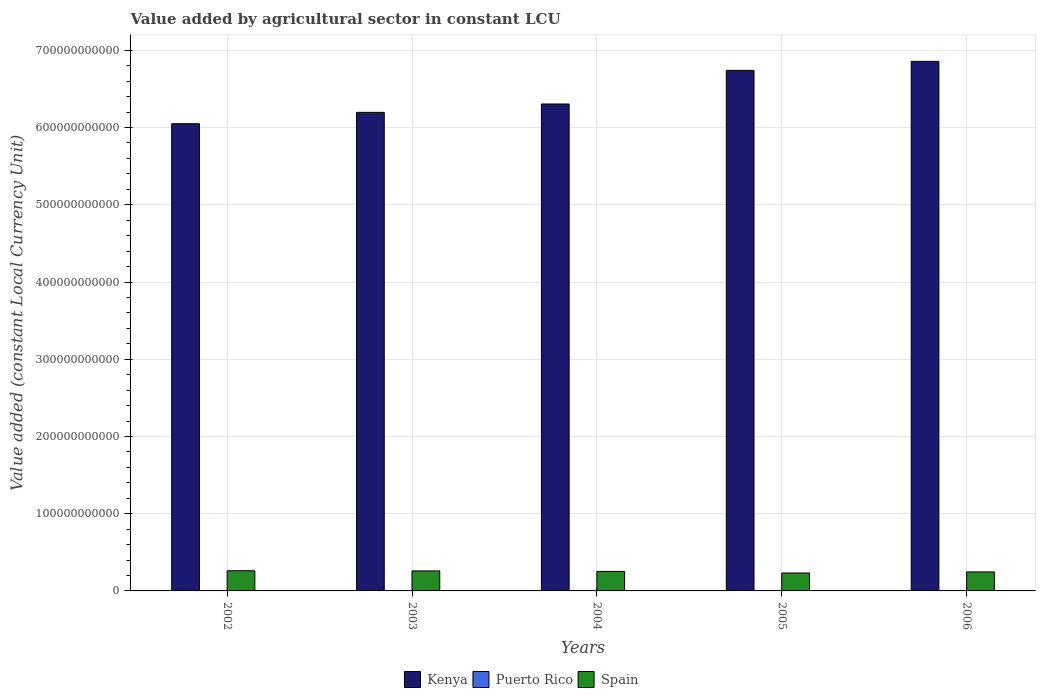Are the number of bars per tick equal to the number of legend labels?
Make the answer very short. Yes. What is the value added by agricultural sector in Spain in 2004?
Your response must be concise. 2.53e+1. Across all years, what is the maximum value added by agricultural sector in Puerto Rico?
Provide a short and direct response. 1.61e+08. Across all years, what is the minimum value added by agricultural sector in Spain?
Make the answer very short. 2.32e+1. In which year was the value added by agricultural sector in Kenya maximum?
Provide a succinct answer. 2006. In which year was the value added by agricultural sector in Puerto Rico minimum?
Make the answer very short. 2002. What is the total value added by agricultural sector in Spain in the graph?
Offer a very short reply. 1.25e+11. What is the difference between the value added by agricultural sector in Kenya in 2003 and that in 2005?
Provide a succinct answer. -5.44e+1. What is the difference between the value added by agricultural sector in Kenya in 2006 and the value added by agricultural sector in Spain in 2004?
Offer a terse response. 6.60e+11. What is the average value added by agricultural sector in Puerto Rico per year?
Provide a short and direct response. 1.40e+08. In the year 2002, what is the difference between the value added by agricultural sector in Puerto Rico and value added by agricultural sector in Kenya?
Offer a very short reply. -6.05e+11. In how many years, is the value added by agricultural sector in Puerto Rico greater than 480000000000 LCU?
Your answer should be compact. 0. What is the ratio of the value added by agricultural sector in Spain in 2002 to that in 2006?
Make the answer very short. 1.06. Is the value added by agricultural sector in Puerto Rico in 2002 less than that in 2006?
Offer a terse response. Yes. What is the difference between the highest and the second highest value added by agricultural sector in Puerto Rico?
Keep it short and to the point. 1.14e+07. What is the difference between the highest and the lowest value added by agricultural sector in Kenya?
Provide a short and direct response. 8.07e+1. In how many years, is the value added by agricultural sector in Kenya greater than the average value added by agricultural sector in Kenya taken over all years?
Offer a terse response. 2. Is the sum of the value added by agricultural sector in Spain in 2003 and 2005 greater than the maximum value added by agricultural sector in Kenya across all years?
Your answer should be compact. No. What does the 1st bar from the left in 2003 represents?
Give a very brief answer. Kenya. What does the 3rd bar from the right in 2003 represents?
Your answer should be compact. Kenya. Are all the bars in the graph horizontal?
Offer a very short reply. No. How many years are there in the graph?
Your response must be concise. 5. What is the difference between two consecutive major ticks on the Y-axis?
Your response must be concise. 1.00e+11. Are the values on the major ticks of Y-axis written in scientific E-notation?
Your answer should be compact. No. What is the title of the graph?
Your response must be concise. Value added by agricultural sector in constant LCU. Does "Norway" appear as one of the legend labels in the graph?
Your response must be concise. No. What is the label or title of the Y-axis?
Provide a short and direct response. Value added (constant Local Currency Unit). What is the Value added (constant Local Currency Unit) of Kenya in 2002?
Ensure brevity in your answer.  6.05e+11. What is the Value added (constant Local Currency Unit) in Puerto Rico in 2002?
Your response must be concise. 1.13e+08. What is the Value added (constant Local Currency Unit) of Spain in 2002?
Your answer should be compact. 2.61e+1. What is the Value added (constant Local Currency Unit) of Kenya in 2003?
Make the answer very short. 6.20e+11. What is the Value added (constant Local Currency Unit) of Puerto Rico in 2003?
Offer a terse response. 1.30e+08. What is the Value added (constant Local Currency Unit) of Spain in 2003?
Give a very brief answer. 2.59e+1. What is the Value added (constant Local Currency Unit) of Kenya in 2004?
Offer a terse response. 6.31e+11. What is the Value added (constant Local Currency Unit) of Puerto Rico in 2004?
Your response must be concise. 1.61e+08. What is the Value added (constant Local Currency Unit) in Spain in 2004?
Provide a succinct answer. 2.53e+1. What is the Value added (constant Local Currency Unit) in Kenya in 2005?
Provide a succinct answer. 6.74e+11. What is the Value added (constant Local Currency Unit) in Puerto Rico in 2005?
Offer a terse response. 1.49e+08. What is the Value added (constant Local Currency Unit) of Spain in 2005?
Provide a succinct answer. 2.32e+1. What is the Value added (constant Local Currency Unit) of Kenya in 2006?
Provide a short and direct response. 6.86e+11. What is the Value added (constant Local Currency Unit) of Puerto Rico in 2006?
Ensure brevity in your answer.  1.50e+08. What is the Value added (constant Local Currency Unit) of Spain in 2006?
Your answer should be compact. 2.46e+1. Across all years, what is the maximum Value added (constant Local Currency Unit) of Kenya?
Keep it short and to the point. 6.86e+11. Across all years, what is the maximum Value added (constant Local Currency Unit) of Puerto Rico?
Ensure brevity in your answer.  1.61e+08. Across all years, what is the maximum Value added (constant Local Currency Unit) in Spain?
Your answer should be very brief. 2.61e+1. Across all years, what is the minimum Value added (constant Local Currency Unit) of Kenya?
Provide a succinct answer. 6.05e+11. Across all years, what is the minimum Value added (constant Local Currency Unit) of Puerto Rico?
Provide a short and direct response. 1.13e+08. Across all years, what is the minimum Value added (constant Local Currency Unit) of Spain?
Your response must be concise. 2.32e+1. What is the total Value added (constant Local Currency Unit) of Kenya in the graph?
Ensure brevity in your answer.  3.21e+12. What is the total Value added (constant Local Currency Unit) in Puerto Rico in the graph?
Provide a short and direct response. 7.02e+08. What is the total Value added (constant Local Currency Unit) of Spain in the graph?
Your response must be concise. 1.25e+11. What is the difference between the Value added (constant Local Currency Unit) in Kenya in 2002 and that in 2003?
Provide a short and direct response. -1.47e+1. What is the difference between the Value added (constant Local Currency Unit) of Puerto Rico in 2002 and that in 2003?
Your response must be concise. -1.62e+07. What is the difference between the Value added (constant Local Currency Unit) in Spain in 2002 and that in 2003?
Keep it short and to the point. 2.04e+08. What is the difference between the Value added (constant Local Currency Unit) in Kenya in 2002 and that in 2004?
Your response must be concise. -2.55e+1. What is the difference between the Value added (constant Local Currency Unit) in Puerto Rico in 2002 and that in 2004?
Provide a succinct answer. -4.76e+07. What is the difference between the Value added (constant Local Currency Unit) of Spain in 2002 and that in 2004?
Offer a very short reply. 8.60e+08. What is the difference between the Value added (constant Local Currency Unit) in Kenya in 2002 and that in 2005?
Ensure brevity in your answer.  -6.91e+1. What is the difference between the Value added (constant Local Currency Unit) in Puerto Rico in 2002 and that in 2005?
Your answer should be very brief. -3.53e+07. What is the difference between the Value added (constant Local Currency Unit) in Spain in 2002 and that in 2005?
Keep it short and to the point. 2.89e+09. What is the difference between the Value added (constant Local Currency Unit) in Kenya in 2002 and that in 2006?
Provide a short and direct response. -8.07e+1. What is the difference between the Value added (constant Local Currency Unit) of Puerto Rico in 2002 and that in 2006?
Your response must be concise. -3.62e+07. What is the difference between the Value added (constant Local Currency Unit) in Spain in 2002 and that in 2006?
Your answer should be very brief. 1.51e+09. What is the difference between the Value added (constant Local Currency Unit) in Kenya in 2003 and that in 2004?
Your response must be concise. -1.08e+1. What is the difference between the Value added (constant Local Currency Unit) in Puerto Rico in 2003 and that in 2004?
Provide a succinct answer. -3.14e+07. What is the difference between the Value added (constant Local Currency Unit) in Spain in 2003 and that in 2004?
Provide a short and direct response. 6.56e+08. What is the difference between the Value added (constant Local Currency Unit) in Kenya in 2003 and that in 2005?
Keep it short and to the point. -5.44e+1. What is the difference between the Value added (constant Local Currency Unit) of Puerto Rico in 2003 and that in 2005?
Provide a succinct answer. -1.91e+07. What is the difference between the Value added (constant Local Currency Unit) in Spain in 2003 and that in 2005?
Offer a terse response. 2.68e+09. What is the difference between the Value added (constant Local Currency Unit) in Kenya in 2003 and that in 2006?
Your answer should be compact. -6.60e+1. What is the difference between the Value added (constant Local Currency Unit) in Puerto Rico in 2003 and that in 2006?
Offer a very short reply. -2.00e+07. What is the difference between the Value added (constant Local Currency Unit) in Spain in 2003 and that in 2006?
Give a very brief answer. 1.31e+09. What is the difference between the Value added (constant Local Currency Unit) in Kenya in 2004 and that in 2005?
Provide a short and direct response. -4.35e+1. What is the difference between the Value added (constant Local Currency Unit) of Puerto Rico in 2004 and that in 2005?
Your answer should be compact. 1.24e+07. What is the difference between the Value added (constant Local Currency Unit) of Spain in 2004 and that in 2005?
Keep it short and to the point. 2.03e+09. What is the difference between the Value added (constant Local Currency Unit) of Kenya in 2004 and that in 2006?
Provide a succinct answer. -5.52e+1. What is the difference between the Value added (constant Local Currency Unit) in Puerto Rico in 2004 and that in 2006?
Provide a short and direct response. 1.14e+07. What is the difference between the Value added (constant Local Currency Unit) of Spain in 2004 and that in 2006?
Your answer should be very brief. 6.53e+08. What is the difference between the Value added (constant Local Currency Unit) in Kenya in 2005 and that in 2006?
Offer a very short reply. -1.17e+1. What is the difference between the Value added (constant Local Currency Unit) in Puerto Rico in 2005 and that in 2006?
Your answer should be compact. -9.53e+05. What is the difference between the Value added (constant Local Currency Unit) of Spain in 2005 and that in 2006?
Provide a succinct answer. -1.38e+09. What is the difference between the Value added (constant Local Currency Unit) of Kenya in 2002 and the Value added (constant Local Currency Unit) of Puerto Rico in 2003?
Provide a succinct answer. 6.05e+11. What is the difference between the Value added (constant Local Currency Unit) of Kenya in 2002 and the Value added (constant Local Currency Unit) of Spain in 2003?
Provide a short and direct response. 5.79e+11. What is the difference between the Value added (constant Local Currency Unit) of Puerto Rico in 2002 and the Value added (constant Local Currency Unit) of Spain in 2003?
Offer a very short reply. -2.58e+1. What is the difference between the Value added (constant Local Currency Unit) in Kenya in 2002 and the Value added (constant Local Currency Unit) in Puerto Rico in 2004?
Provide a succinct answer. 6.05e+11. What is the difference between the Value added (constant Local Currency Unit) in Kenya in 2002 and the Value added (constant Local Currency Unit) in Spain in 2004?
Ensure brevity in your answer.  5.80e+11. What is the difference between the Value added (constant Local Currency Unit) in Puerto Rico in 2002 and the Value added (constant Local Currency Unit) in Spain in 2004?
Keep it short and to the point. -2.51e+1. What is the difference between the Value added (constant Local Currency Unit) of Kenya in 2002 and the Value added (constant Local Currency Unit) of Puerto Rico in 2005?
Offer a very short reply. 6.05e+11. What is the difference between the Value added (constant Local Currency Unit) in Kenya in 2002 and the Value added (constant Local Currency Unit) in Spain in 2005?
Give a very brief answer. 5.82e+11. What is the difference between the Value added (constant Local Currency Unit) in Puerto Rico in 2002 and the Value added (constant Local Currency Unit) in Spain in 2005?
Offer a terse response. -2.31e+1. What is the difference between the Value added (constant Local Currency Unit) in Kenya in 2002 and the Value added (constant Local Currency Unit) in Puerto Rico in 2006?
Provide a short and direct response. 6.05e+11. What is the difference between the Value added (constant Local Currency Unit) in Kenya in 2002 and the Value added (constant Local Currency Unit) in Spain in 2006?
Your response must be concise. 5.80e+11. What is the difference between the Value added (constant Local Currency Unit) of Puerto Rico in 2002 and the Value added (constant Local Currency Unit) of Spain in 2006?
Your answer should be compact. -2.45e+1. What is the difference between the Value added (constant Local Currency Unit) of Kenya in 2003 and the Value added (constant Local Currency Unit) of Puerto Rico in 2004?
Your answer should be very brief. 6.20e+11. What is the difference between the Value added (constant Local Currency Unit) in Kenya in 2003 and the Value added (constant Local Currency Unit) in Spain in 2004?
Give a very brief answer. 5.94e+11. What is the difference between the Value added (constant Local Currency Unit) in Puerto Rico in 2003 and the Value added (constant Local Currency Unit) in Spain in 2004?
Make the answer very short. -2.51e+1. What is the difference between the Value added (constant Local Currency Unit) in Kenya in 2003 and the Value added (constant Local Currency Unit) in Puerto Rico in 2005?
Give a very brief answer. 6.20e+11. What is the difference between the Value added (constant Local Currency Unit) in Kenya in 2003 and the Value added (constant Local Currency Unit) in Spain in 2005?
Offer a terse response. 5.96e+11. What is the difference between the Value added (constant Local Currency Unit) of Puerto Rico in 2003 and the Value added (constant Local Currency Unit) of Spain in 2005?
Your answer should be very brief. -2.31e+1. What is the difference between the Value added (constant Local Currency Unit) in Kenya in 2003 and the Value added (constant Local Currency Unit) in Puerto Rico in 2006?
Make the answer very short. 6.20e+11. What is the difference between the Value added (constant Local Currency Unit) in Kenya in 2003 and the Value added (constant Local Currency Unit) in Spain in 2006?
Your response must be concise. 5.95e+11. What is the difference between the Value added (constant Local Currency Unit) of Puerto Rico in 2003 and the Value added (constant Local Currency Unit) of Spain in 2006?
Your answer should be very brief. -2.45e+1. What is the difference between the Value added (constant Local Currency Unit) of Kenya in 2004 and the Value added (constant Local Currency Unit) of Puerto Rico in 2005?
Your answer should be very brief. 6.30e+11. What is the difference between the Value added (constant Local Currency Unit) of Kenya in 2004 and the Value added (constant Local Currency Unit) of Spain in 2005?
Offer a terse response. 6.07e+11. What is the difference between the Value added (constant Local Currency Unit) of Puerto Rico in 2004 and the Value added (constant Local Currency Unit) of Spain in 2005?
Give a very brief answer. -2.31e+1. What is the difference between the Value added (constant Local Currency Unit) of Kenya in 2004 and the Value added (constant Local Currency Unit) of Puerto Rico in 2006?
Offer a terse response. 6.30e+11. What is the difference between the Value added (constant Local Currency Unit) in Kenya in 2004 and the Value added (constant Local Currency Unit) in Spain in 2006?
Offer a very short reply. 6.06e+11. What is the difference between the Value added (constant Local Currency Unit) in Puerto Rico in 2004 and the Value added (constant Local Currency Unit) in Spain in 2006?
Offer a terse response. -2.44e+1. What is the difference between the Value added (constant Local Currency Unit) of Kenya in 2005 and the Value added (constant Local Currency Unit) of Puerto Rico in 2006?
Your answer should be compact. 6.74e+11. What is the difference between the Value added (constant Local Currency Unit) in Kenya in 2005 and the Value added (constant Local Currency Unit) in Spain in 2006?
Your answer should be compact. 6.49e+11. What is the difference between the Value added (constant Local Currency Unit) of Puerto Rico in 2005 and the Value added (constant Local Currency Unit) of Spain in 2006?
Offer a very short reply. -2.45e+1. What is the average Value added (constant Local Currency Unit) of Kenya per year?
Offer a terse response. 6.43e+11. What is the average Value added (constant Local Currency Unit) of Puerto Rico per year?
Ensure brevity in your answer.  1.40e+08. What is the average Value added (constant Local Currency Unit) in Spain per year?
Offer a terse response. 2.50e+1. In the year 2002, what is the difference between the Value added (constant Local Currency Unit) of Kenya and Value added (constant Local Currency Unit) of Puerto Rico?
Your answer should be compact. 6.05e+11. In the year 2002, what is the difference between the Value added (constant Local Currency Unit) of Kenya and Value added (constant Local Currency Unit) of Spain?
Provide a short and direct response. 5.79e+11. In the year 2002, what is the difference between the Value added (constant Local Currency Unit) of Puerto Rico and Value added (constant Local Currency Unit) of Spain?
Your answer should be compact. -2.60e+1. In the year 2003, what is the difference between the Value added (constant Local Currency Unit) of Kenya and Value added (constant Local Currency Unit) of Puerto Rico?
Offer a terse response. 6.20e+11. In the year 2003, what is the difference between the Value added (constant Local Currency Unit) of Kenya and Value added (constant Local Currency Unit) of Spain?
Your answer should be compact. 5.94e+11. In the year 2003, what is the difference between the Value added (constant Local Currency Unit) in Puerto Rico and Value added (constant Local Currency Unit) in Spain?
Provide a succinct answer. -2.58e+1. In the year 2004, what is the difference between the Value added (constant Local Currency Unit) in Kenya and Value added (constant Local Currency Unit) in Puerto Rico?
Offer a very short reply. 6.30e+11. In the year 2004, what is the difference between the Value added (constant Local Currency Unit) of Kenya and Value added (constant Local Currency Unit) of Spain?
Offer a very short reply. 6.05e+11. In the year 2004, what is the difference between the Value added (constant Local Currency Unit) in Puerto Rico and Value added (constant Local Currency Unit) in Spain?
Offer a terse response. -2.51e+1. In the year 2005, what is the difference between the Value added (constant Local Currency Unit) of Kenya and Value added (constant Local Currency Unit) of Puerto Rico?
Make the answer very short. 6.74e+11. In the year 2005, what is the difference between the Value added (constant Local Currency Unit) of Kenya and Value added (constant Local Currency Unit) of Spain?
Your answer should be compact. 6.51e+11. In the year 2005, what is the difference between the Value added (constant Local Currency Unit) of Puerto Rico and Value added (constant Local Currency Unit) of Spain?
Your response must be concise. -2.31e+1. In the year 2006, what is the difference between the Value added (constant Local Currency Unit) of Kenya and Value added (constant Local Currency Unit) of Puerto Rico?
Give a very brief answer. 6.86e+11. In the year 2006, what is the difference between the Value added (constant Local Currency Unit) in Kenya and Value added (constant Local Currency Unit) in Spain?
Offer a very short reply. 6.61e+11. In the year 2006, what is the difference between the Value added (constant Local Currency Unit) in Puerto Rico and Value added (constant Local Currency Unit) in Spain?
Ensure brevity in your answer.  -2.45e+1. What is the ratio of the Value added (constant Local Currency Unit) in Kenya in 2002 to that in 2003?
Your answer should be very brief. 0.98. What is the ratio of the Value added (constant Local Currency Unit) in Puerto Rico in 2002 to that in 2003?
Offer a very short reply. 0.88. What is the ratio of the Value added (constant Local Currency Unit) of Spain in 2002 to that in 2003?
Offer a very short reply. 1.01. What is the ratio of the Value added (constant Local Currency Unit) of Kenya in 2002 to that in 2004?
Your response must be concise. 0.96. What is the ratio of the Value added (constant Local Currency Unit) of Puerto Rico in 2002 to that in 2004?
Provide a succinct answer. 0.7. What is the ratio of the Value added (constant Local Currency Unit) in Spain in 2002 to that in 2004?
Provide a short and direct response. 1.03. What is the ratio of the Value added (constant Local Currency Unit) in Kenya in 2002 to that in 2005?
Offer a terse response. 0.9. What is the ratio of the Value added (constant Local Currency Unit) of Puerto Rico in 2002 to that in 2005?
Ensure brevity in your answer.  0.76. What is the ratio of the Value added (constant Local Currency Unit) of Spain in 2002 to that in 2005?
Offer a terse response. 1.12. What is the ratio of the Value added (constant Local Currency Unit) in Kenya in 2002 to that in 2006?
Keep it short and to the point. 0.88. What is the ratio of the Value added (constant Local Currency Unit) of Puerto Rico in 2002 to that in 2006?
Make the answer very short. 0.76. What is the ratio of the Value added (constant Local Currency Unit) of Spain in 2002 to that in 2006?
Make the answer very short. 1.06. What is the ratio of the Value added (constant Local Currency Unit) in Kenya in 2003 to that in 2004?
Offer a very short reply. 0.98. What is the ratio of the Value added (constant Local Currency Unit) of Puerto Rico in 2003 to that in 2004?
Your response must be concise. 0.8. What is the ratio of the Value added (constant Local Currency Unit) in Spain in 2003 to that in 2004?
Offer a terse response. 1.03. What is the ratio of the Value added (constant Local Currency Unit) of Kenya in 2003 to that in 2005?
Your answer should be very brief. 0.92. What is the ratio of the Value added (constant Local Currency Unit) in Puerto Rico in 2003 to that in 2005?
Provide a short and direct response. 0.87. What is the ratio of the Value added (constant Local Currency Unit) of Spain in 2003 to that in 2005?
Give a very brief answer. 1.12. What is the ratio of the Value added (constant Local Currency Unit) in Kenya in 2003 to that in 2006?
Give a very brief answer. 0.9. What is the ratio of the Value added (constant Local Currency Unit) in Puerto Rico in 2003 to that in 2006?
Your answer should be compact. 0.87. What is the ratio of the Value added (constant Local Currency Unit) in Spain in 2003 to that in 2006?
Keep it short and to the point. 1.05. What is the ratio of the Value added (constant Local Currency Unit) of Kenya in 2004 to that in 2005?
Provide a short and direct response. 0.94. What is the ratio of the Value added (constant Local Currency Unit) of Spain in 2004 to that in 2005?
Provide a short and direct response. 1.09. What is the ratio of the Value added (constant Local Currency Unit) of Kenya in 2004 to that in 2006?
Make the answer very short. 0.92. What is the ratio of the Value added (constant Local Currency Unit) of Puerto Rico in 2004 to that in 2006?
Ensure brevity in your answer.  1.08. What is the ratio of the Value added (constant Local Currency Unit) in Spain in 2004 to that in 2006?
Your response must be concise. 1.03. What is the ratio of the Value added (constant Local Currency Unit) in Puerto Rico in 2005 to that in 2006?
Your response must be concise. 0.99. What is the ratio of the Value added (constant Local Currency Unit) of Spain in 2005 to that in 2006?
Provide a succinct answer. 0.94. What is the difference between the highest and the second highest Value added (constant Local Currency Unit) in Kenya?
Keep it short and to the point. 1.17e+1. What is the difference between the highest and the second highest Value added (constant Local Currency Unit) of Puerto Rico?
Provide a short and direct response. 1.14e+07. What is the difference between the highest and the second highest Value added (constant Local Currency Unit) in Spain?
Give a very brief answer. 2.04e+08. What is the difference between the highest and the lowest Value added (constant Local Currency Unit) of Kenya?
Give a very brief answer. 8.07e+1. What is the difference between the highest and the lowest Value added (constant Local Currency Unit) of Puerto Rico?
Your response must be concise. 4.76e+07. What is the difference between the highest and the lowest Value added (constant Local Currency Unit) in Spain?
Give a very brief answer. 2.89e+09. 